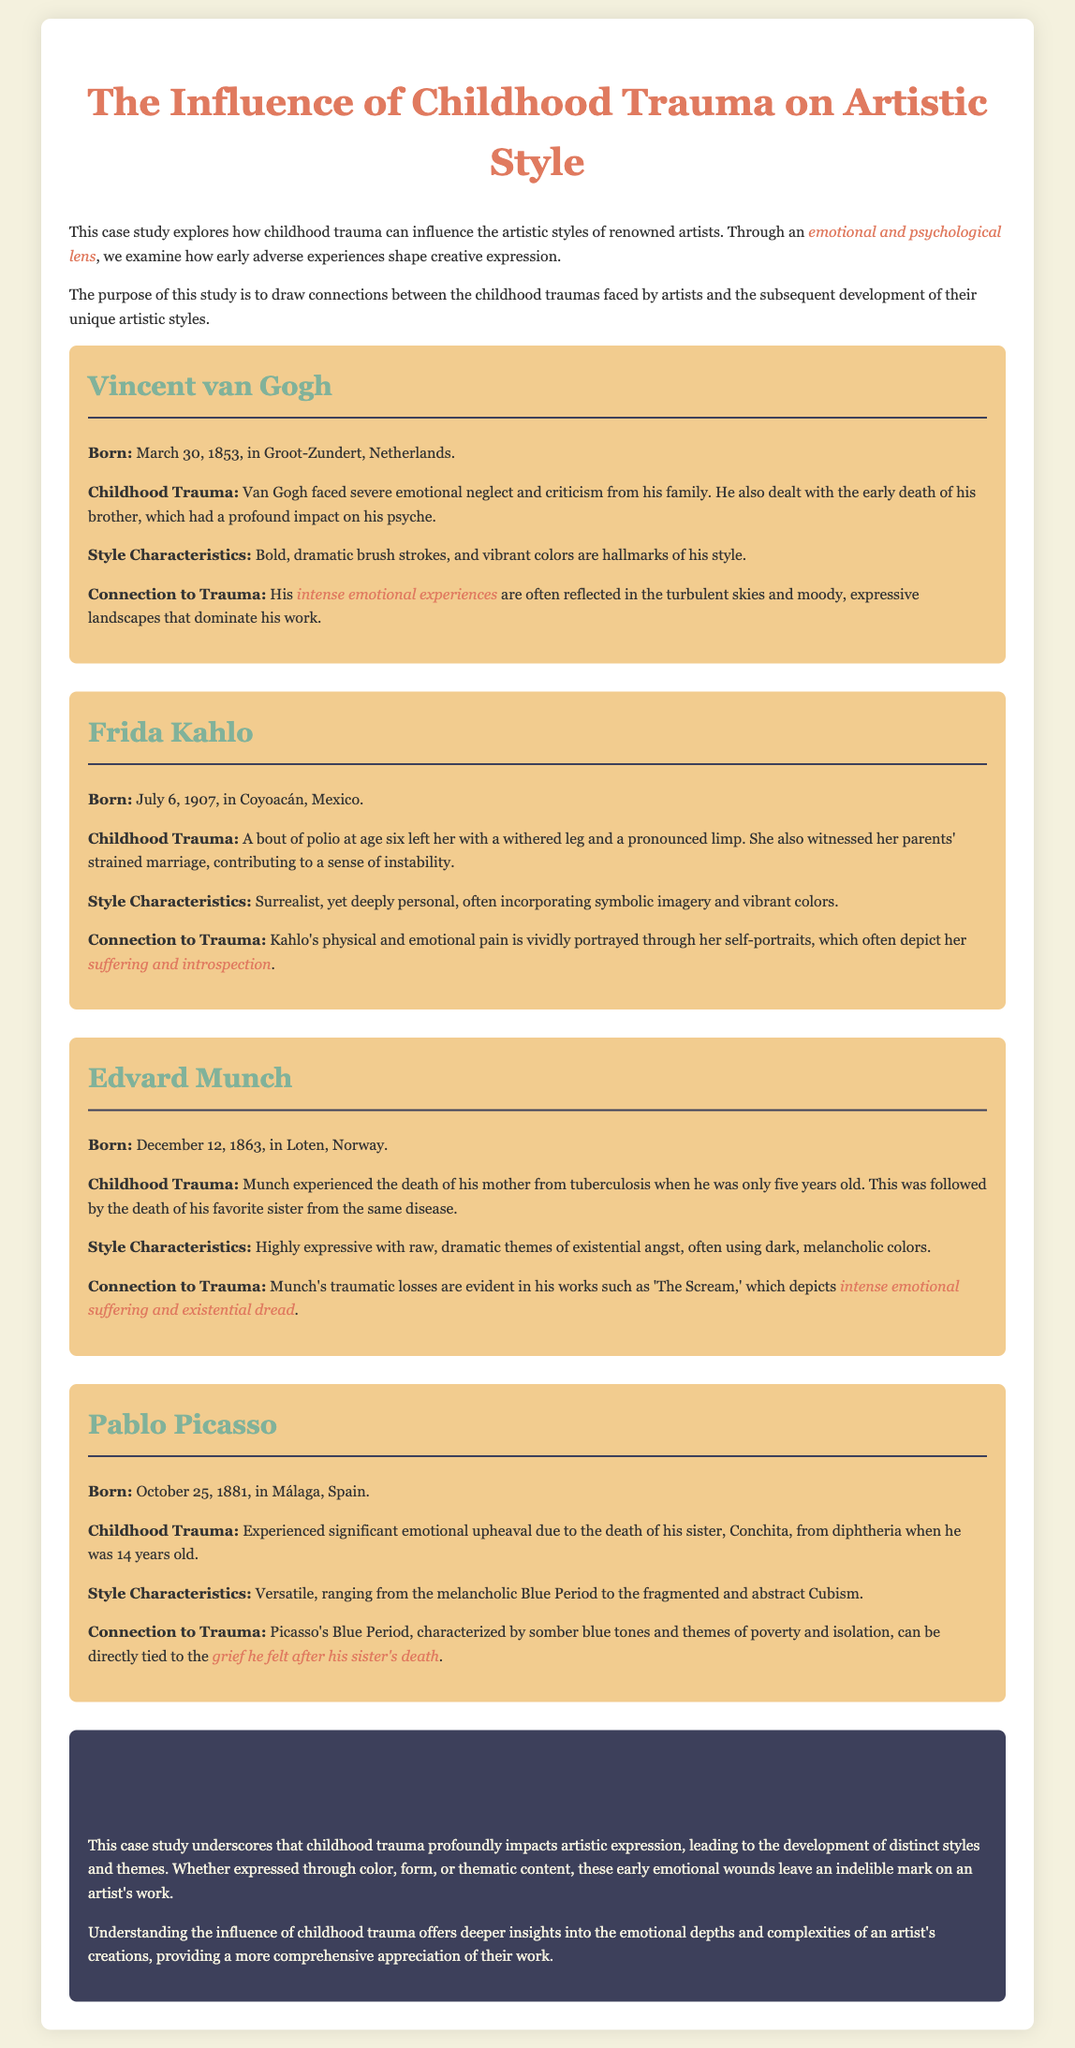What is the title of the case study? The title provides a clear indication of the topic and focus of the document.
Answer: The Influence of Childhood Trauma on Artistic Style Who is the artist born on March 30, 1853? This question identifies a specific artist along with their birthdate listed in the document.
Answer: Vincent van Gogh What childhood trauma did Frida Kahlo experience? The question seeks information explicitly stated about Kahlo's early adverse experiences that affected her.
Answer: Polio Which artist's work includes 'The Scream'? This question asks for the name of the artist associated with a well-known painting discussed in the document.
Answer: Edvard Munch During which period did Picasso’s artistic style lean towards somber blue tones? This question requires the reader to identify a specific artistic phase linked to Picasso's personal experiences.
Answer: Blue Period What impact did Vincent van Gogh’s childhood trauma have on his artistic style? The question requires reasoning about how personal experiences are reflected in specific artwork characteristics discussed.
Answer: Turbulent skies and moody landscapes What is the primary focus of this case study? This question seeks an overarching theme or purpose based on the document's introduction.
Answer: Childhood traumas and artistic styles What type of colors are characteristic of Edvard Munch's style? The question asks for specific stylistic features related to Munch's artwork as described in the document.
Answer: Dark, melancholic colors 